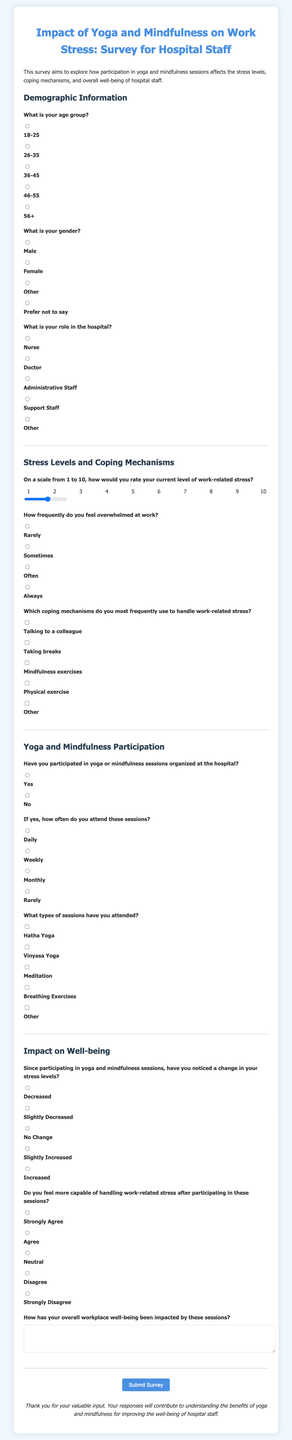What is the title of the survey? The title of the survey is displayed at the top of the document, summarizing its focus.
Answer: Impact of Yoga and Mindfulness on Work Stress: Survey for Hospital Staff What is the age group option for respondents? The document lists several options for the age group during the demographic section.
Answer: 18-25 How frequently do participants feel overwhelmed at work? This question is part of the Stress Levels and Coping Mechanisms section, allowing for several responses.
Answer: Rarely, Sometimes, Often, Always What types of yoga sessions can participants choose from? The document lists different types of yoga and mindfulness sessions that respondents may have attended.
Answer: Hatha Yoga, Vinyasa Yoga, Meditation, Breathing Exercises What aspect of well-being is noted for change due to participation in sessions? The impact on stress levels is specifically mentioned in questions about changes since attending the sessions.
Answer: Stress levels How do participants assess their capability to handle work-related stress after sessions? This question requires respondents to provide their opinion based on their experiences in the sessions.
Answer: Strongly Agree, Agree, Neutral, Disagree, Strongly Disagree What do participants have to submit upon completing the survey? The last element of the document indicates what action is required to finalize the survey.
Answer: Submit Survey What is the background color of the survey form? The design of the document specifies the color theme used for the background.
Answer: #f0f8ff How is the content of the survey structured? The survey is organized into sections that group related questions effectively for the respondents.
Answer: Demographic Information, Stress Levels and Coping Mechanisms, Yoga and Mindfulness Participation, Impact on Well-being What is the conclusion message for respondents? The survey ends with a message expressing gratitude for the participants’ input.
Answer: Thank you for your valuable input 